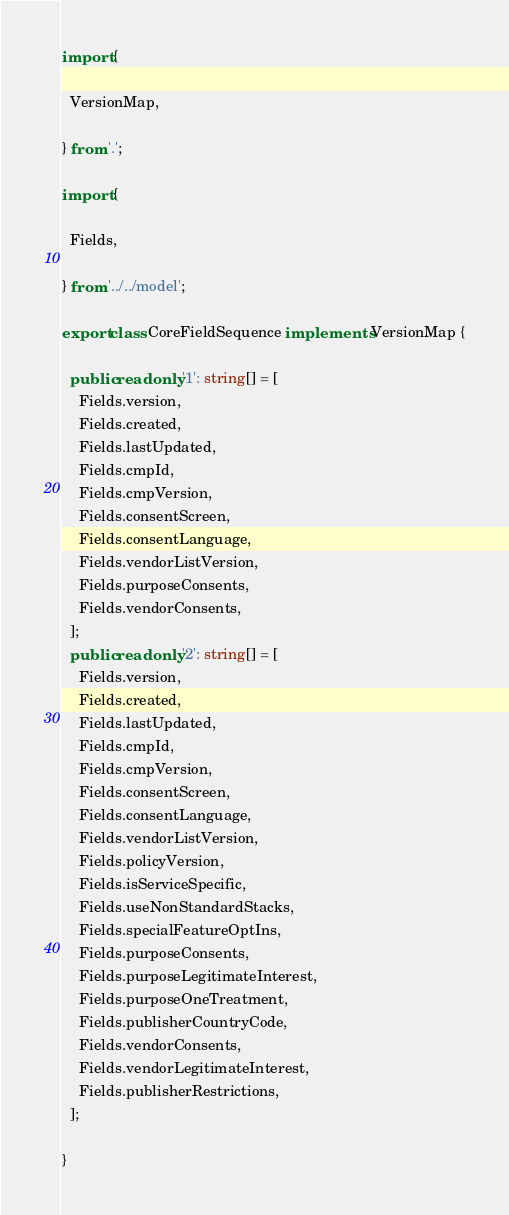Convert code to text. <code><loc_0><loc_0><loc_500><loc_500><_TypeScript_>import {

  VersionMap,

} from '.';

import {

  Fields,

} from '../../model';

export class CoreFieldSequence implements VersionMap {

  public readonly '1': string[] = [
    Fields.version,
    Fields.created,
    Fields.lastUpdated,
    Fields.cmpId,
    Fields.cmpVersion,
    Fields.consentScreen,
    Fields.consentLanguage,
    Fields.vendorListVersion,
    Fields.purposeConsents,
    Fields.vendorConsents,
  ];
  public readonly '2': string[] = [
    Fields.version,
    Fields.created,
    Fields.lastUpdated,
    Fields.cmpId,
    Fields.cmpVersion,
    Fields.consentScreen,
    Fields.consentLanguage,
    Fields.vendorListVersion,
    Fields.policyVersion,
    Fields.isServiceSpecific,
    Fields.useNonStandardStacks,
    Fields.specialFeatureOptIns,
    Fields.purposeConsents,
    Fields.purposeLegitimateInterest,
    Fields.purposeOneTreatment,
    Fields.publisherCountryCode,
    Fields.vendorConsents,
    Fields.vendorLegitimateInterest,
    Fields.publisherRestrictions,
  ];

}
</code> 